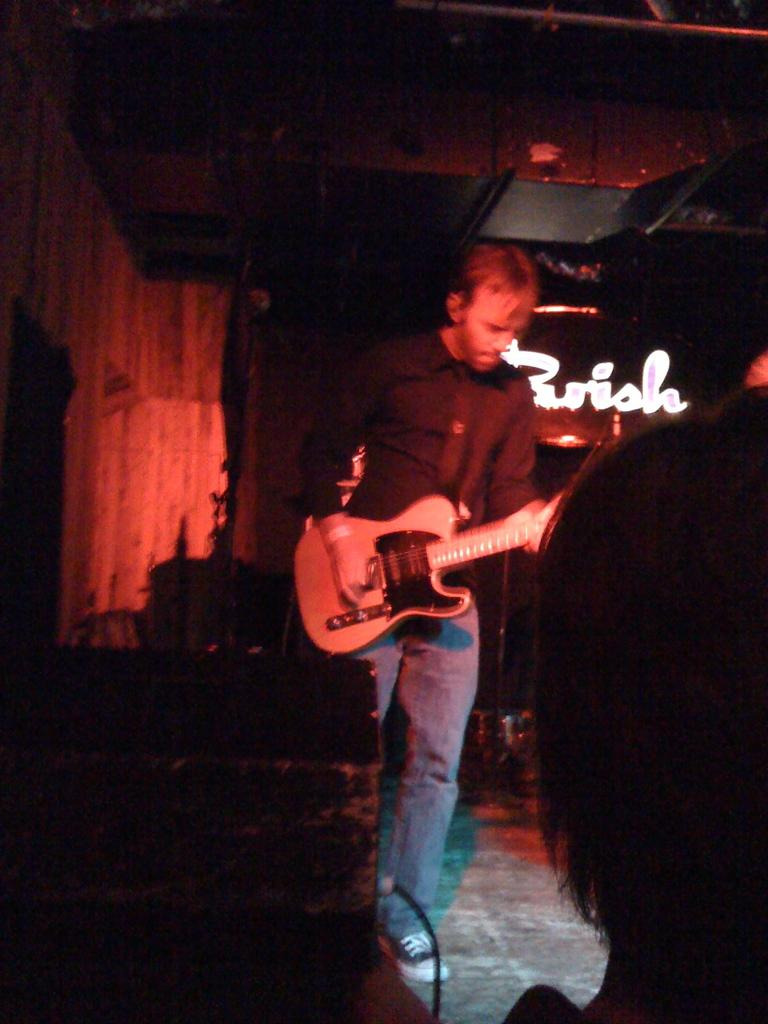What is the main subject of the image? There is a person in the image. What is the person holding in the image? The person is holding a guitar. Where can the mint be found in the image? There is no mint present in the image. What type of basket is being used by the person in the image? There is no basket present in the image. 